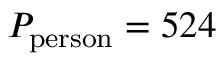Convert formula to latex. <formula><loc_0><loc_0><loc_500><loc_500>P _ { p e r s o n } = 5 2 4</formula> 